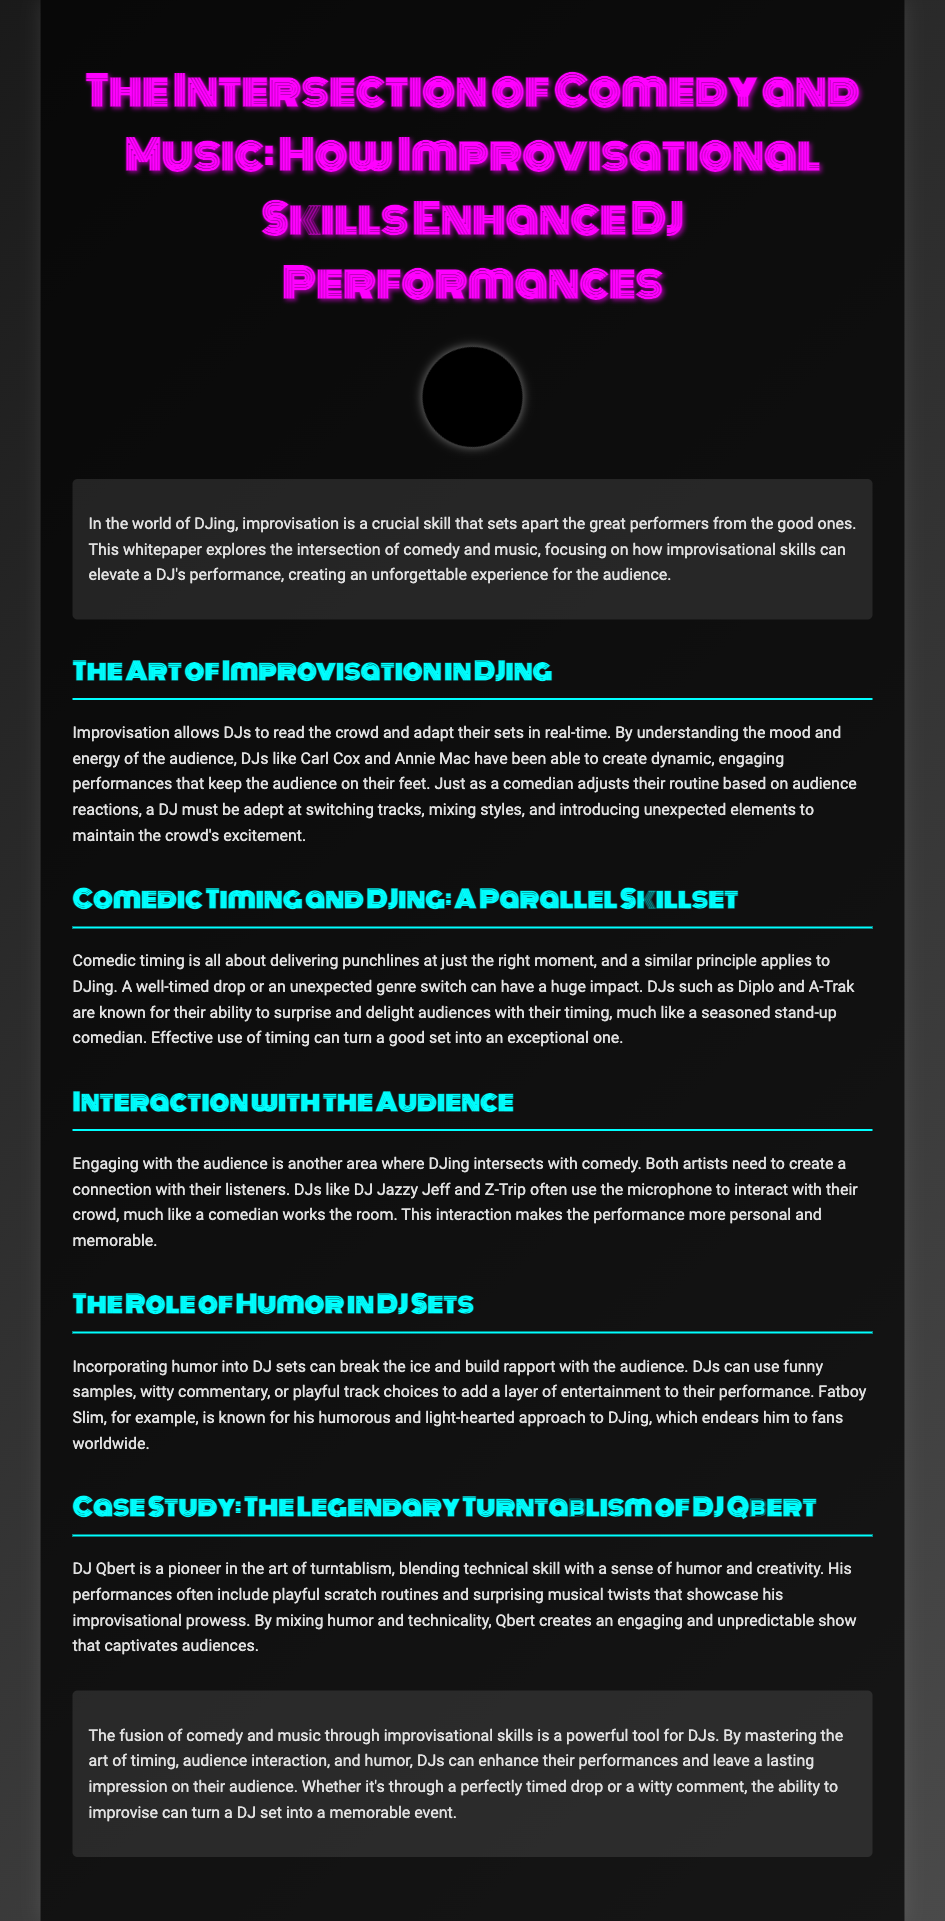What is the title of the whitepaper? The title of the whitepaper is mentioned in the document header.
Answer: The Intersection of Comedy and Music: How Improvisational Skills Enhance DJ Performances Who is mentioned as a pioneer in turntablism? The document includes a section about a specific DJ known for turntablism.
Answer: DJ Qbert Which DJ is highlighted for humor in his DJ sets? The document discusses a specific DJ known for his humorous approach to performances.
Answer: Fatboy Slim What artistic skill allows DJs to adapt their performances? The document highlights a specific skill essential for DJs when performing live.
Answer: Improvisation Which section discusses audience interaction? The document has clearly defined sections, one of which focuses on how DJs engage with the crowd.
Answer: Interaction with the Audience Which DJs are noted for their comedic timing? A section describes DJs recognized for their timing in performances, similar to comedians.
Answer: Diplo and A-Trak What is a key element that enhances DJ performances according to the conclusion? The conclusion emphasizes an important skill that DJs can develop to improve their shows.
Answer: Improvisational skills How does humor contribute to a DJ's performance? The document explains a way in which humor benefits DJ shows.
Answer: It breaks the ice and builds rapport 